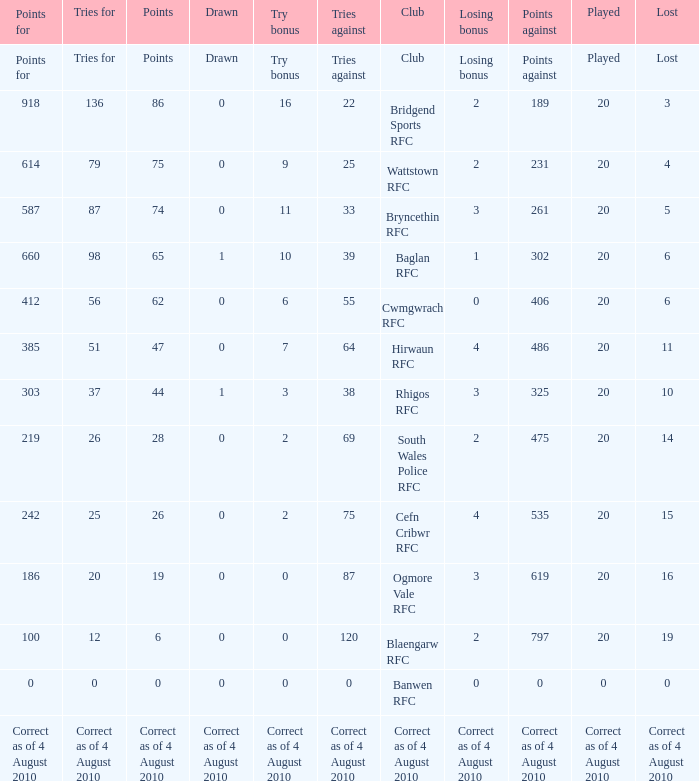What is the points against when drawn is drawn? Points against. 